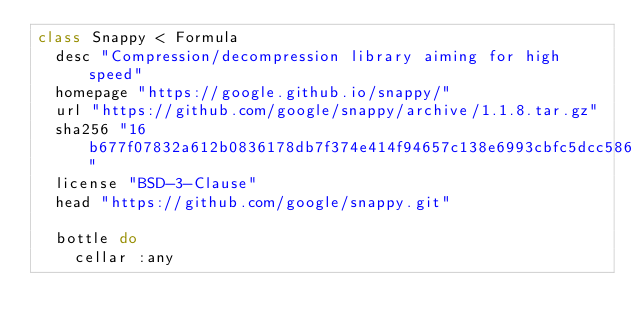Convert code to text. <code><loc_0><loc_0><loc_500><loc_500><_Ruby_>class Snappy < Formula
  desc "Compression/decompression library aiming for high speed"
  homepage "https://google.github.io/snappy/"
  url "https://github.com/google/snappy/archive/1.1.8.tar.gz"
  sha256 "16b677f07832a612b0836178db7f374e414f94657c138e6993cbfc5dcc58651f"
  license "BSD-3-Clause"
  head "https://github.com/google/snappy.git"

  bottle do
    cellar :any</code> 